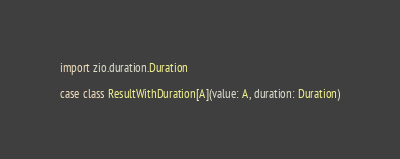Convert code to text. <code><loc_0><loc_0><loc_500><loc_500><_Scala_>
import zio.duration.Duration

case class ResultWithDuration[A](value: A, duration: Duration)
</code> 